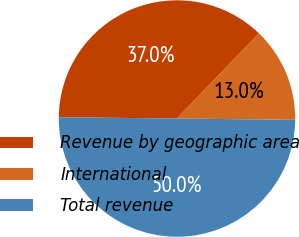<chart> <loc_0><loc_0><loc_500><loc_500><pie_chart><fcel>Revenue by geographic area<fcel>International<fcel>Total revenue<nl><fcel>37.02%<fcel>12.98%<fcel>50.0%<nl></chart> 